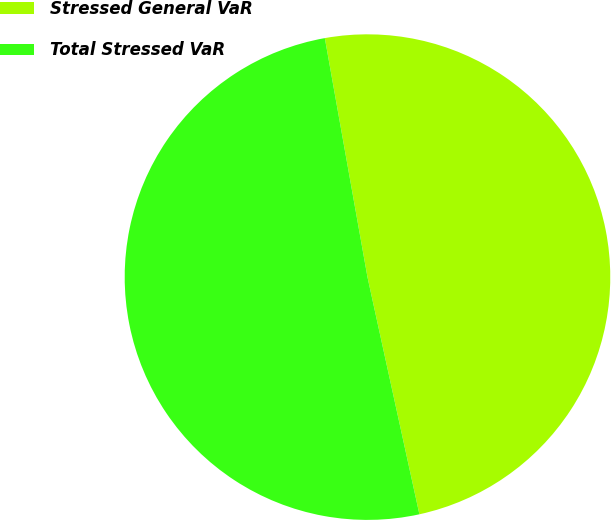Convert chart to OTSL. <chart><loc_0><loc_0><loc_500><loc_500><pie_chart><fcel>Stressed General VaR<fcel>Total Stressed VaR<nl><fcel>49.38%<fcel>50.62%<nl></chart> 